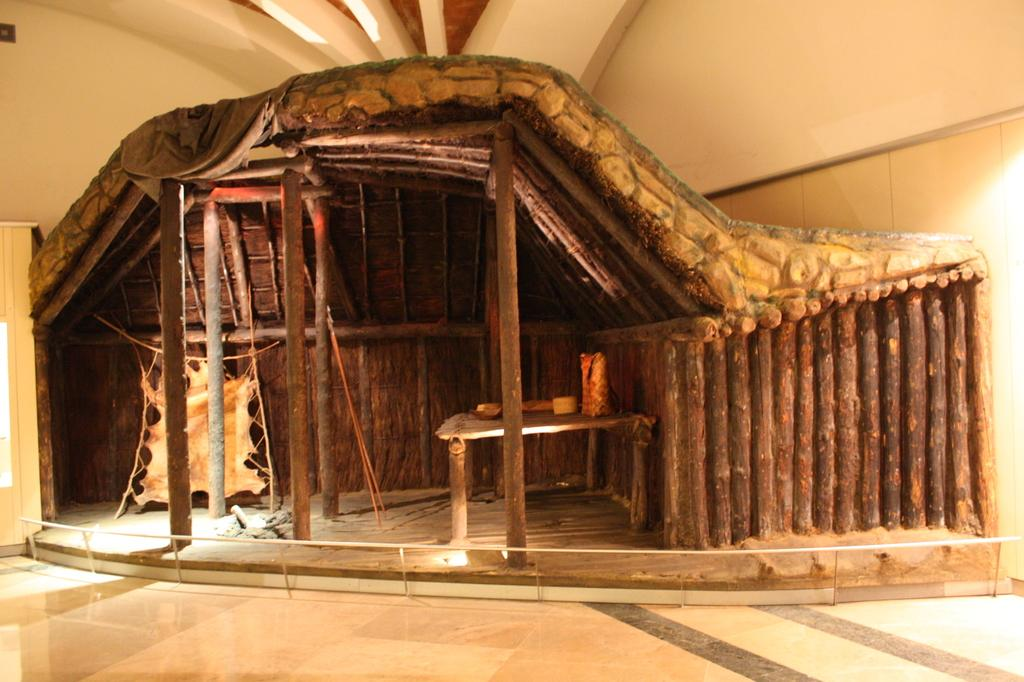What type of setting is shown in the image? The image depicts an inside view of a room. What materials can be seen in the construction of the room? There is a wooden construction and metal rods in the room. How many ducks are sitting on the wooden construction in the image? There are no ducks present in the image; it only shows a wooden construction and metal rods in a room. 